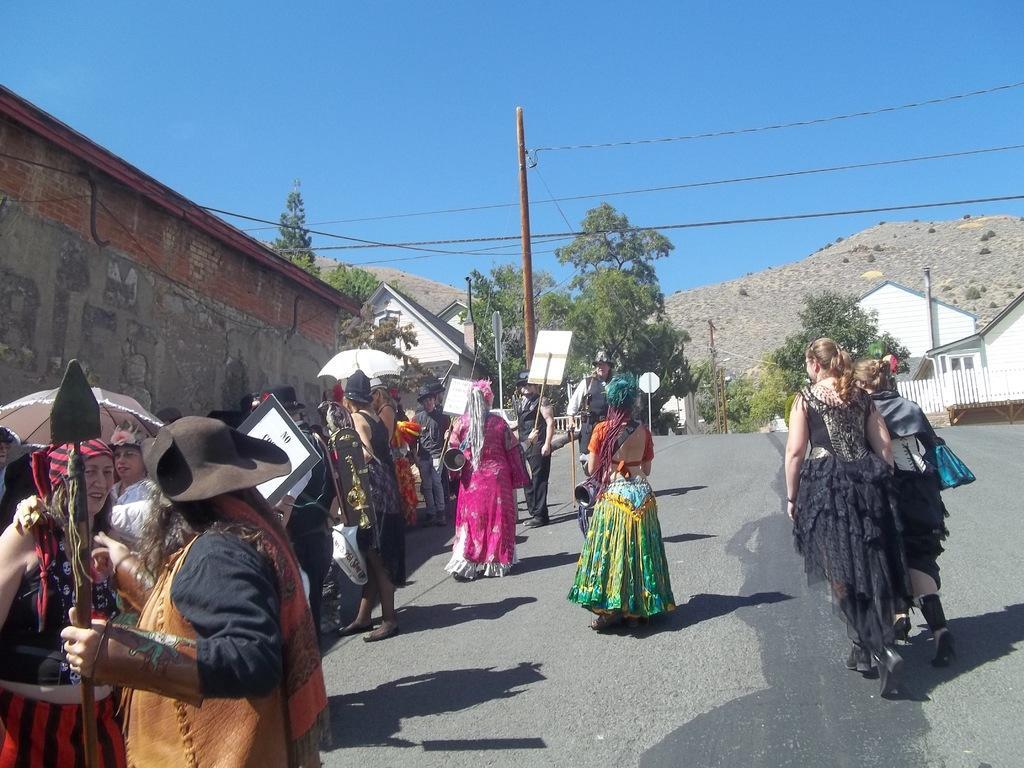Can you describe this image briefly? In this picture, we see people wearing colorful dresses are walking on the road and they are holding boards and umbrellas in their hands. In front of them, we see a pole and wires. There are many buildings and trees in the background. We even see hills. At the top of the picture, we see the sky. 